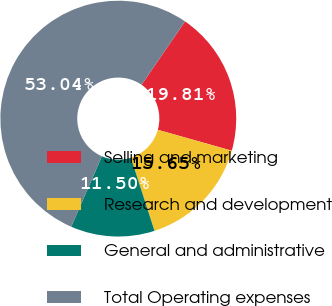<chart> <loc_0><loc_0><loc_500><loc_500><pie_chart><fcel>Selling and marketing<fcel>Research and development<fcel>General and administrative<fcel>Total Operating expenses<nl><fcel>19.81%<fcel>15.65%<fcel>11.5%<fcel>53.04%<nl></chart> 